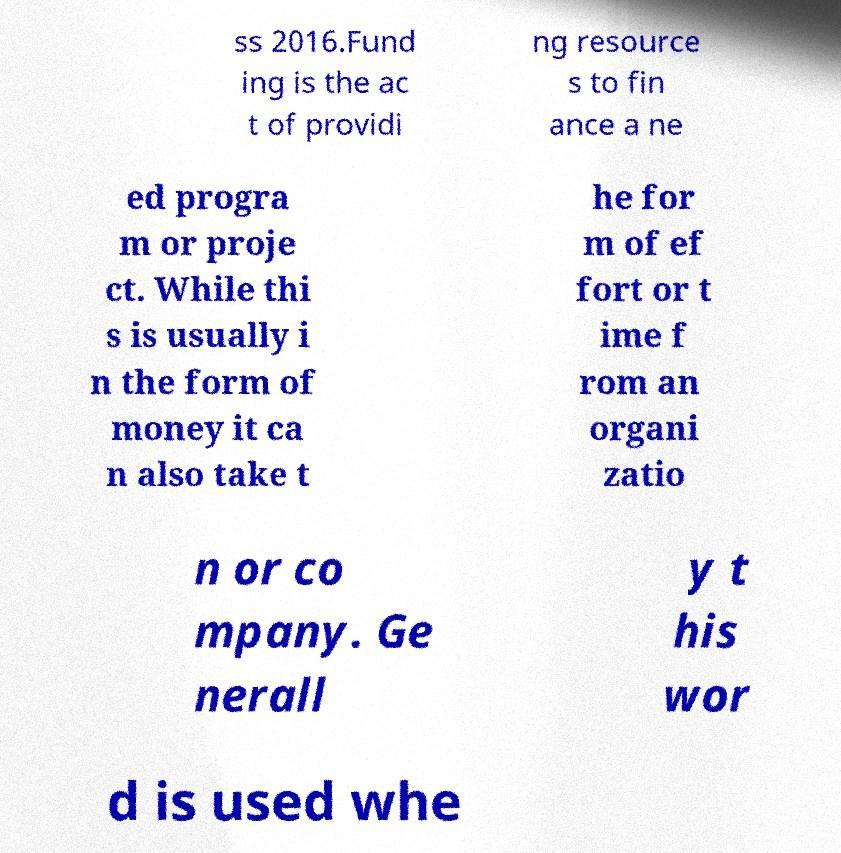I need the written content from this picture converted into text. Can you do that? ss 2016.Fund ing is the ac t of providi ng resource s to fin ance a ne ed progra m or proje ct. While thi s is usually i n the form of money it ca n also take t he for m of ef fort or t ime f rom an organi zatio n or co mpany. Ge nerall y t his wor d is used whe 